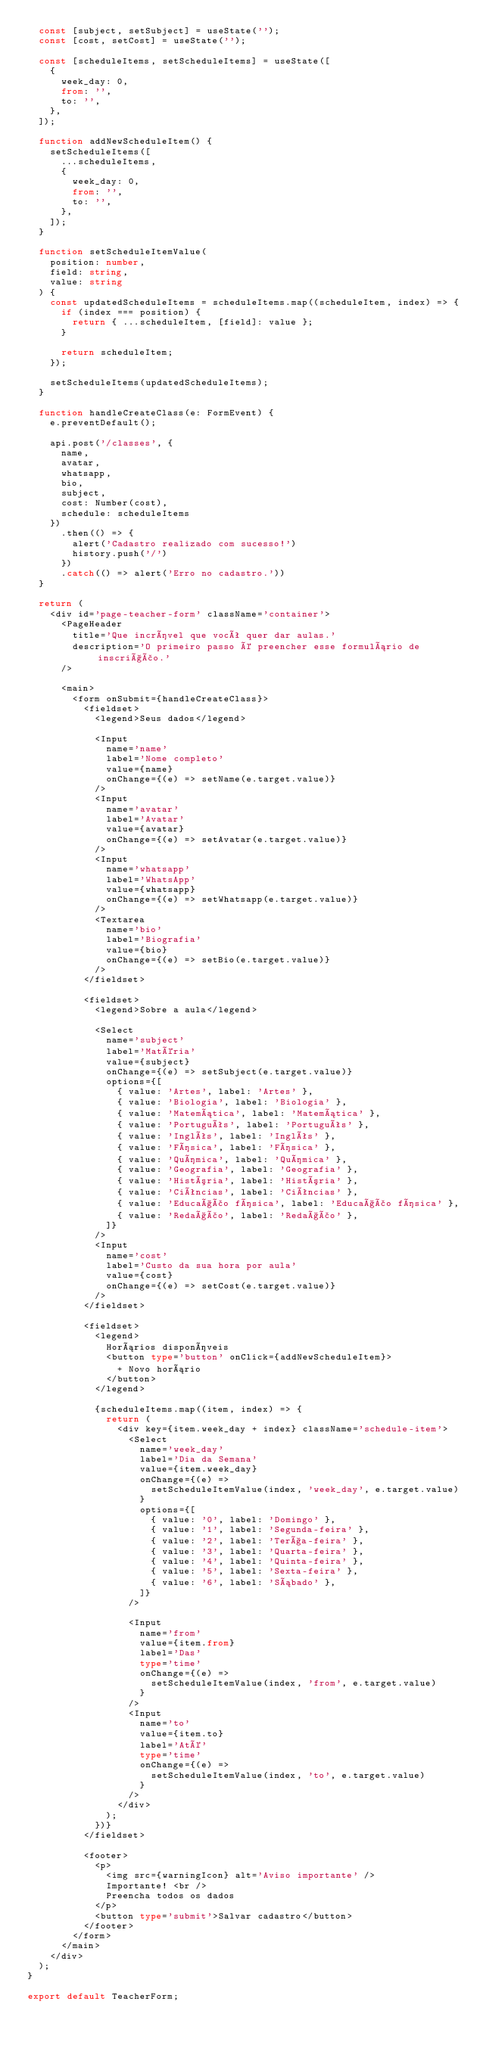<code> <loc_0><loc_0><loc_500><loc_500><_TypeScript_>  const [subject, setSubject] = useState('');
  const [cost, setCost] = useState('');

  const [scheduleItems, setScheduleItems] = useState([
    {
      week_day: 0,
      from: '',
      to: '',
    },
  ]);

  function addNewScheduleItem() {
    setScheduleItems([
      ...scheduleItems,
      {
        week_day: 0,
        from: '',
        to: '',
      },
    ]);
  }

  function setScheduleItemValue(
    position: number,
    field: string,
    value: string
  ) {
    const updatedScheduleItems = scheduleItems.map((scheduleItem, index) => {
      if (index === position) {
        return { ...scheduleItem, [field]: value };
      }

      return scheduleItem;
    });

    setScheduleItems(updatedScheduleItems);
  }

  function handleCreateClass(e: FormEvent) {
    e.preventDefault();

    api.post('/classes', {
      name,
      avatar,
      whatsapp,
      bio,
      subject,
      cost: Number(cost),
      schedule: scheduleItems
    })
      .then(() => {
        alert('Cadastro realizado com sucesso!')
        history.push('/')
      })
      .catch(() => alert('Erro no cadastro.'))
  }

  return (
    <div id='page-teacher-form' className='container'>
      <PageHeader
        title='Que incrível que você quer dar aulas.'
        description='O primeiro passo é preencher esse formulário de inscrição.'
      />

      <main>
        <form onSubmit={handleCreateClass}>
          <fieldset>
            <legend>Seus dados</legend>

            <Input
              name='name'
              label='Nome completo'
              value={name}
              onChange={(e) => setName(e.target.value)}
            />
            <Input
              name='avatar'
              label='Avatar'
              value={avatar}
              onChange={(e) => setAvatar(e.target.value)}
            />
            <Input
              name='whatsapp'
              label='WhatsApp'
              value={whatsapp}
              onChange={(e) => setWhatsapp(e.target.value)}
            />
            <Textarea
              name='bio'
              label='Biografia'
              value={bio}
              onChange={(e) => setBio(e.target.value)}
            />
          </fieldset>

          <fieldset>
            <legend>Sobre a aula</legend>

            <Select
              name='subject'
              label='Matéria'
              value={subject}
              onChange={(e) => setSubject(e.target.value)}
              options={[
                { value: 'Artes', label: 'Artes' },
                { value: 'Biologia', label: 'Biologia' },
                { value: 'Matemática', label: 'Matemática' },
                { value: 'Português', label: 'Português' },
                { value: 'Inglês', label: 'Inglês' },
                { value: 'Física', label: 'Física' },
                { value: 'Química', label: 'Química' },
                { value: 'Geografia', label: 'Geografia' },
                { value: 'História', label: 'História' },
                { value: 'Ciências', label: 'Ciências' },
                { value: 'Educação física', label: 'Educação física' },
                { value: 'Redação', label: 'Redação' },
              ]}
            />
            <Input
              name='cost'
              label='Custo da sua hora por aula'
              value={cost}
              onChange={(e) => setCost(e.target.value)}
            />
          </fieldset>

          <fieldset>
            <legend>
              Horários disponíveis
              <button type='button' onClick={addNewScheduleItem}>
                + Novo horário
              </button>
            </legend>

            {scheduleItems.map((item, index) => {
              return (
                <div key={item.week_day + index} className='schedule-item'>
                  <Select
                    name='week_day'
                    label='Dia da Semana'
                    value={item.week_day}
                    onChange={(e) =>
                      setScheduleItemValue(index, 'week_day', e.target.value)
                    }
                    options={[
                      { value: '0', label: 'Domingo' },
                      { value: '1', label: 'Segunda-feira' },
                      { value: '2', label: 'Terça-feira' },
                      { value: '3', label: 'Quarta-feira' },
                      { value: '4', label: 'Quinta-feira' },
                      { value: '5', label: 'Sexta-feira' },
                      { value: '6', label: 'Sábado' },
                    ]}
                  />

                  <Input
                    name='from'
                    value={item.from}
                    label='Das'
                    type='time'
                    onChange={(e) =>
                      setScheduleItemValue(index, 'from', e.target.value)
                    }
                  />
                  <Input
                    name='to'
                    value={item.to}
                    label='Até'
                    type='time'
                    onChange={(e) =>
                      setScheduleItemValue(index, 'to', e.target.value)
                    }
                  />
                </div>
              );
            })}
          </fieldset>

          <footer>
            <p>
              <img src={warningIcon} alt='Aviso importante' />
              Importante! <br />
              Preencha todos os dados
            </p>
            <button type='submit'>Salvar cadastro</button>
          </footer>
        </form>
      </main>
    </div>
  );
}

export default TeacherForm;
</code> 